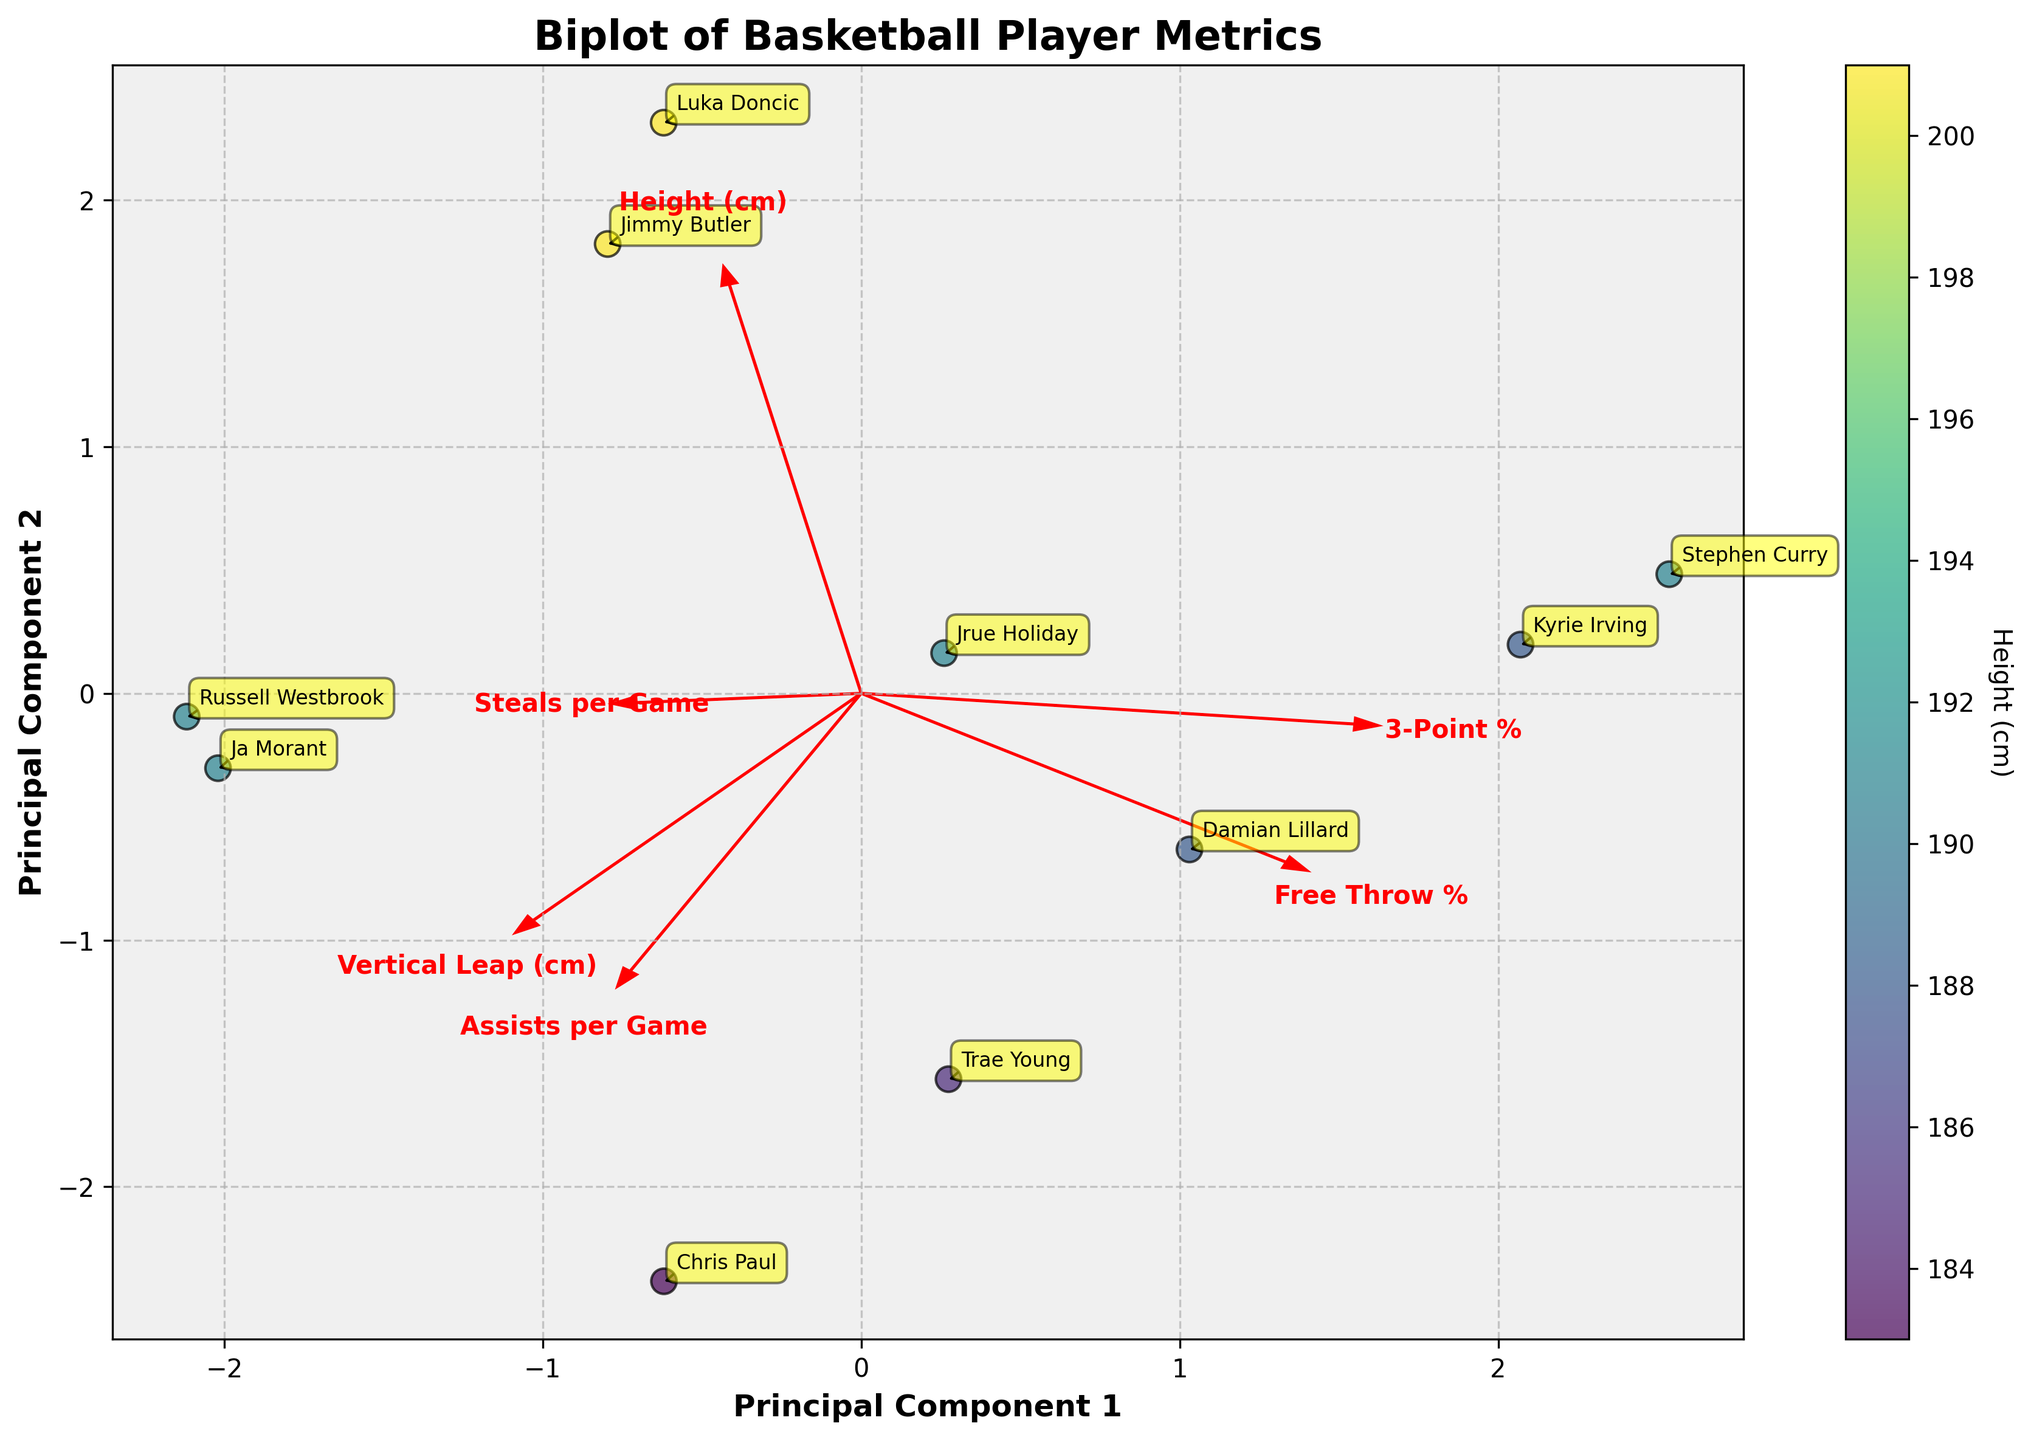1. What is the title of the biplot? The title is typically placed at the top of the plot and provides a summary of what the graph is about.
Answer: Biplot of Basketball Player Metrics 2. How many players are represented in the biplot? By counting the number of unique annotations (player names) shown on the plot, we can determine the number of players.
Answer: 10 3. Which player is positioned farthest along Principal Component 1? This can be determined by looking at the plot and identifying the player farthest to the right or left on the x-axis.
Answer: Stephen Curry 4. Which players have the highest vertical leap based on their position on the biplot? This can be determined by finding the players that align closest with the direction of the eigenvector representing "Vertical Leap (cm)" on the plot.
Answer: Ja Morant and Russell Westbrook 5. How do the heights of the players compare on the biplot? Height is represented by color on the plot, with a color gradient. Players in shades associated with taller heights (e.g., yellow/green spectrum) can be compared to those in shorter shades (blue spectrum).
Answer: Taller players are Luka Doncic and Jimmy Butler; shorter players are Chris Paul and Trae Young 6. What relationships can you infer between "Assists per Game" and "3-Point %" based on the eigenvectors' directions? By examining the angles and directions of the eigenvectors, we can infer whether the variables are positively or negatively correlated. Directions closer together indicate a positive relationship, while directions further apart or opposite indicate a negative or no relationship.
Answer: Weak positive relationship 7. What does the direction of the eignevector for "Free Throw %" suggest about its correlation with Principal Component 1? The direction of the eigenvector relative to Principal Component 1 informs us about the strength and nature of the correlation. If it points largely in the direction of PC1, there's a strong correlation.
Answer: Strong positive correlation 8. Between Chris Paul and Ja Morant, who has the higher Principal Component 2 value and why? Compare the positions of Chris Paul and Ja Morant along the y-axis of the plot. The player higher on the y-axis has the higher PC2 value.
Answer: Ja Morant because he is higher on the y-axis 9. Which player has the lowest performance on Principal Component 2 and what might this indicate? Identify the player closest to the bottom of the y-axis. This might indicate lower performance on the metrics most heavily weighted on PC2.
Answer: Kyrie Irving 10. Based on the biplot, which physical attribute seems to be least correlated with the technical skills like "Free Throw %" and "3-Point %"? By observing the angles between eigenvectors, if one physical attribute eigenvector is orthogonal or oppositely directed compared to the technical skills' eigenvectors, it suggests little or no correlation.
Answer: Height (cm) 